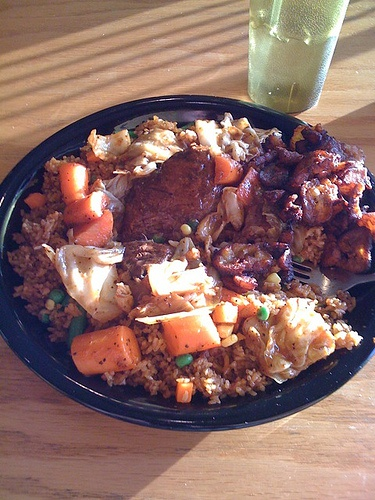Describe the objects in this image and their specific colors. I can see dining table in brown, tan, black, and maroon tones, bowl in gray, black, maroon, brown, and purple tones, cup in gray, darkgray, and ivory tones, carrot in gray, brown, and salmon tones, and carrot in gray, salmon, ivory, and tan tones in this image. 